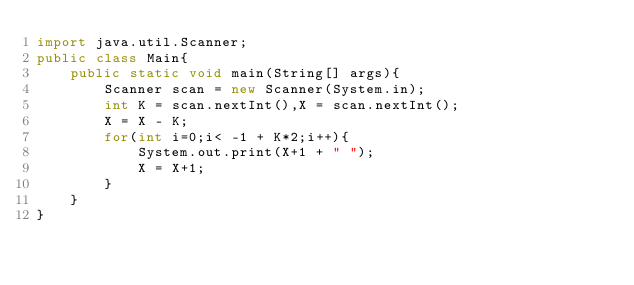<code> <loc_0><loc_0><loc_500><loc_500><_Java_>import java.util.Scanner;
public class Main{
    public static void main(String[] args){
        Scanner scan = new Scanner(System.in);
        int K = scan.nextInt(),X = scan.nextInt();
        X = X - K;
        for(int i=0;i< -1 + K*2;i++){
            System.out.print(X+1 + " ");
            X = X+1;
        }
    }
}</code> 